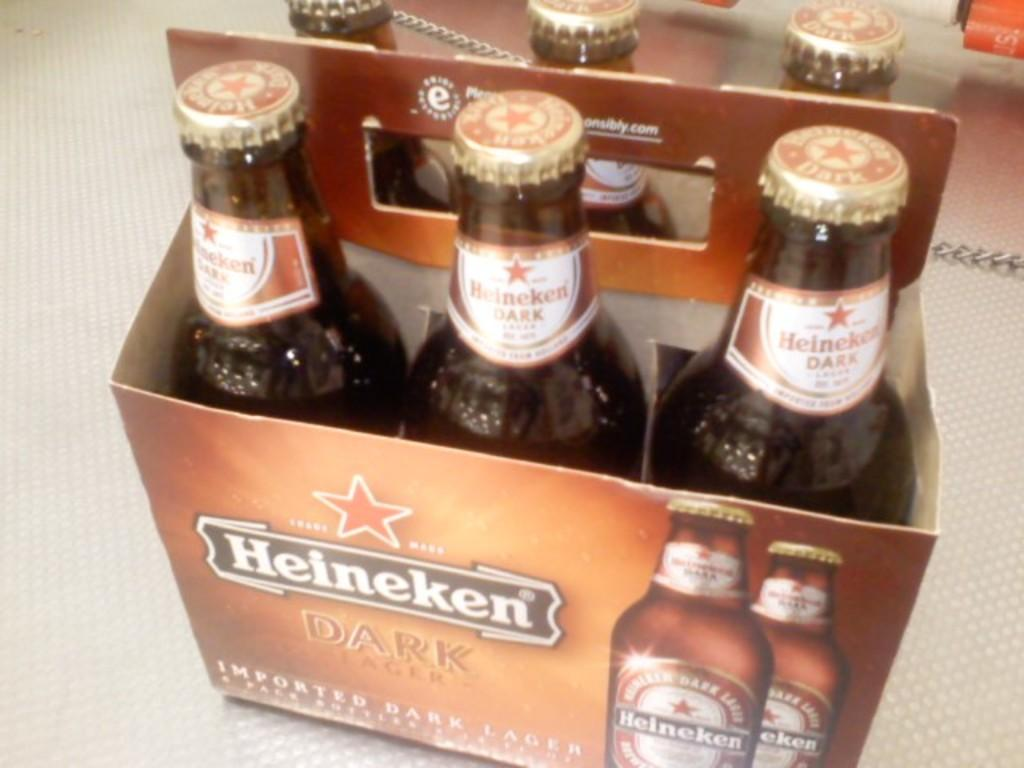Provide a one-sentence caption for the provided image. A sixpack on Heinken Dark Lager sits on a counter. 